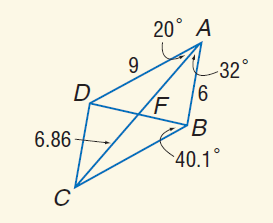Answer the mathemtical geometry problem and directly provide the correct option letter.
Question: Use parallelogram A B C D to find m \angle B D C.
Choices: A: 32 B: 40.1 C: 52 D: 87.9 D 